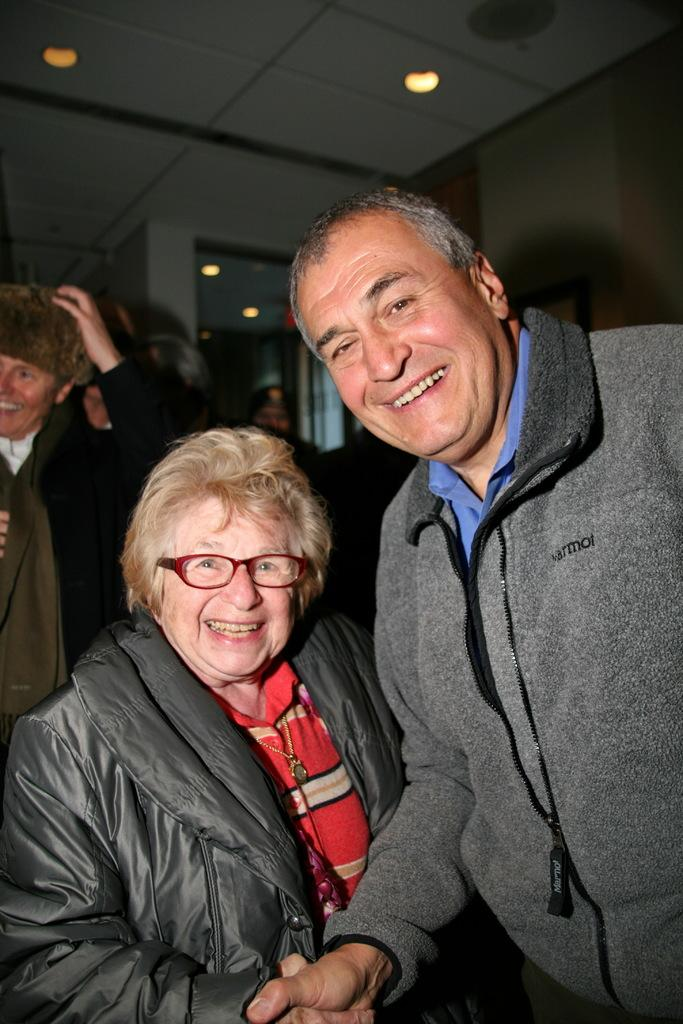How many people are in the image? There are two people in the image. What are the two people doing? The two people are shaking hands. What might be the reason for their interaction? They might be posing for a picture, as stated in the fact. Can you describe the background of the image? There is a group of people in the background of the image. How many frogs can be seen in the image? There are no frogs present in the image. What breed of dogs are visible in the image? There are no dogs present in the image. 